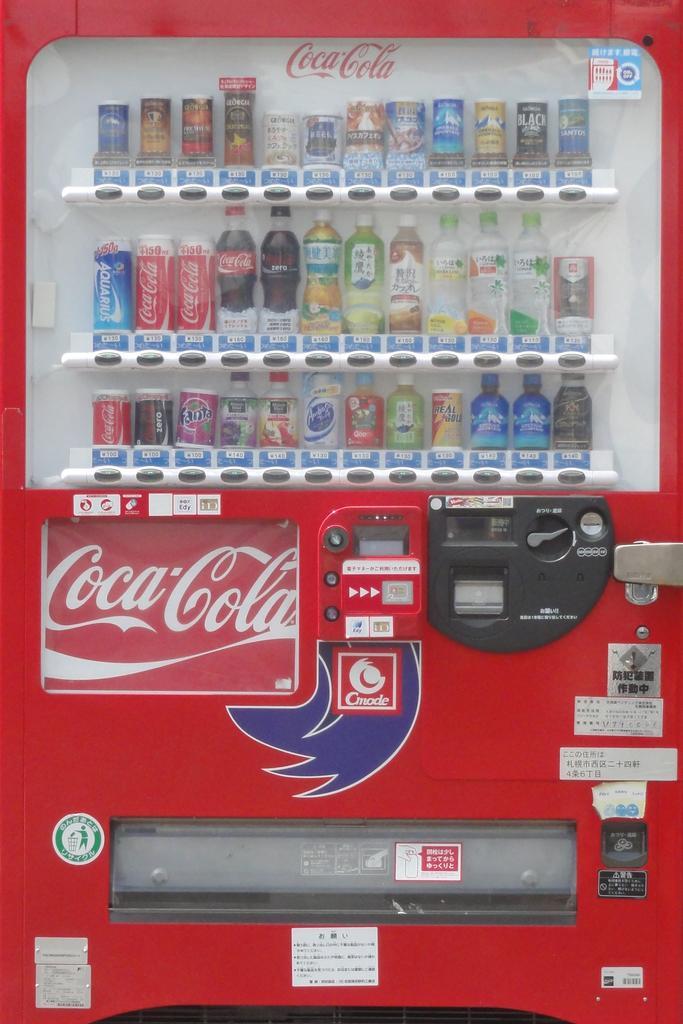What type of cola can you buy from this?
Make the answer very short. Coca cola. What brand is this soda machine?
Your answer should be very brief. Coca cola. What kind of soda machine?
Your answer should be very brief. Coca cola. What brand name is the blue can on the far left of the middle row?
Ensure brevity in your answer.  Unanswerable. 